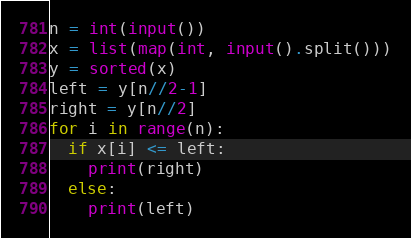Convert code to text. <code><loc_0><loc_0><loc_500><loc_500><_Python_>n = int(input())
x = list(map(int, input().split()))
y = sorted(x)
left = y[n//2-1]
right = y[n//2]
for i in range(n):
  if x[i] <= left:
    print(right)
  else:
    print(left)</code> 